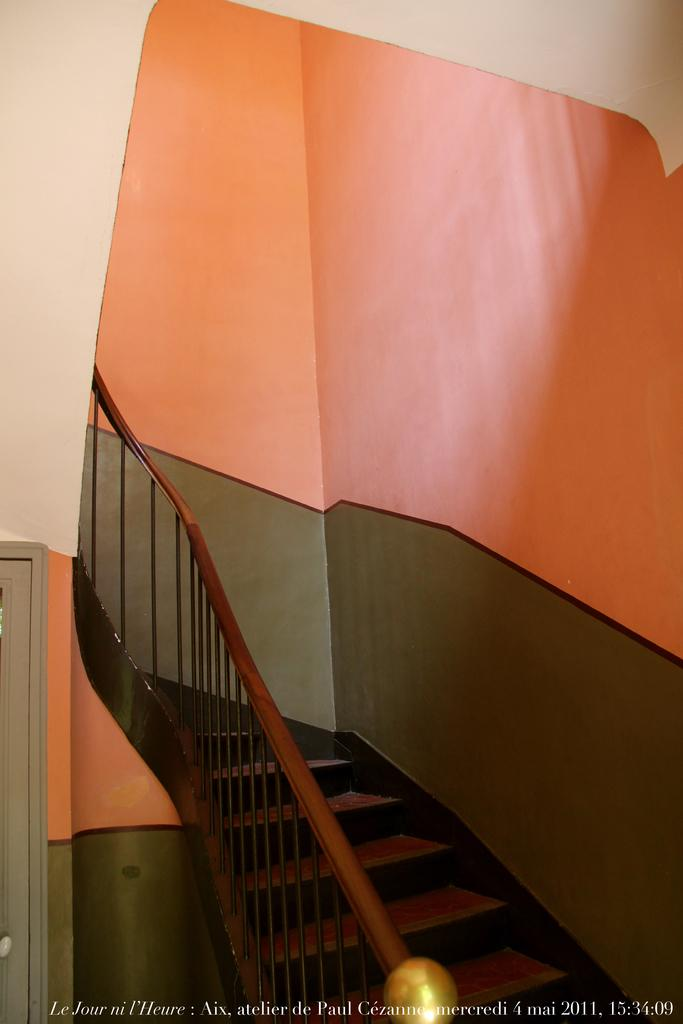What can be seen in the foreground of the image? There are stairs and a fence in the foreground of the image. What is visible in the background of the image? There is a wall in the background of the image. What type of cushion can be seen on the wall in the image? There is no cushion present on the wall in the image. How many stars can be seen in the sky in the image? There is no sky visible in the image, so it is not possible to determine the number of stars. 